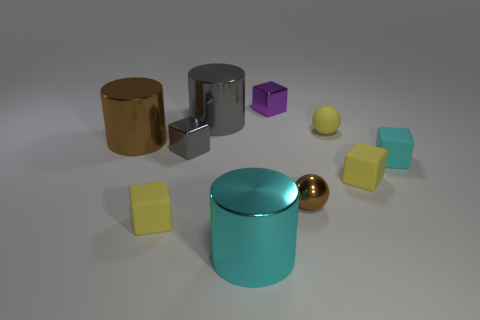Do the purple metallic cube and the cyan matte object have the same size?
Your answer should be compact. Yes. There is a tiny ball that is made of the same material as the tiny gray thing; what is its color?
Your response must be concise. Brown. There is a big thing that is the same color as the shiny sphere; what shape is it?
Provide a short and direct response. Cylinder. Is the number of purple shiny blocks that are to the right of the small purple metal object the same as the number of purple metal things in front of the big gray object?
Your response must be concise. Yes. There is a cyan thing that is in front of the yellow cube right of the rubber sphere; what shape is it?
Provide a succinct answer. Cylinder. There is a cyan thing that is the same shape as the small gray metallic object; what material is it?
Provide a short and direct response. Rubber. There is another sphere that is the same size as the rubber sphere; what color is it?
Offer a very short reply. Brown. Are there the same number of gray shiny blocks that are left of the gray cube and tiny purple rubber cylinders?
Give a very brief answer. Yes. What is the color of the big shiny object that is on the left side of the yellow cube that is on the left side of the tiny purple thing?
Your answer should be compact. Brown. There is a metallic cube that is to the right of the gray metallic thing behind the large brown metallic cylinder; what size is it?
Ensure brevity in your answer.  Small. 